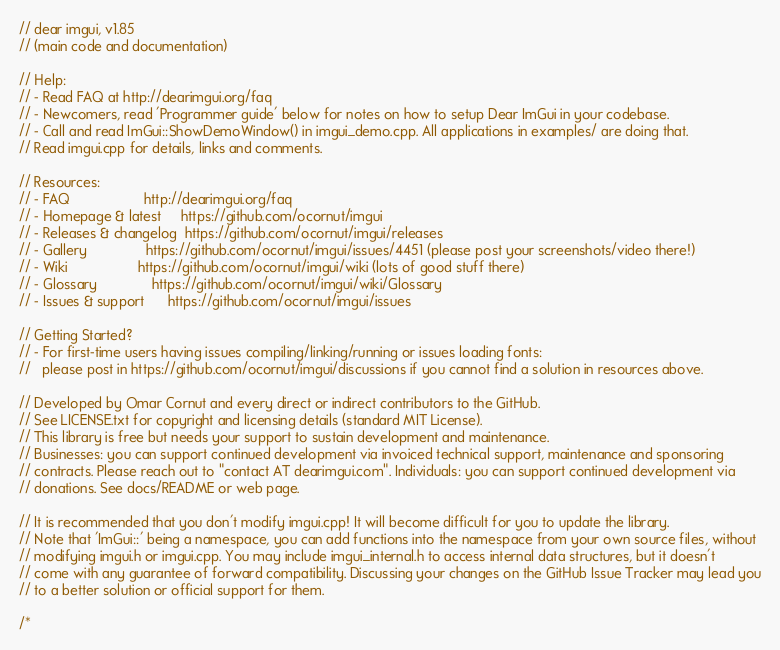<code> <loc_0><loc_0><loc_500><loc_500><_C++_>// dear imgui, v1.85
// (main code and documentation)

// Help:
// - Read FAQ at http://dearimgui.org/faq
// - Newcomers, read 'Programmer guide' below for notes on how to setup Dear ImGui in your codebase.
// - Call and read ImGui::ShowDemoWindow() in imgui_demo.cpp. All applications in examples/ are doing that.
// Read imgui.cpp for details, links and comments.

// Resources:
// - FAQ                   http://dearimgui.org/faq
// - Homepage & latest     https://github.com/ocornut/imgui
// - Releases & changelog  https://github.com/ocornut/imgui/releases
// - Gallery               https://github.com/ocornut/imgui/issues/4451 (please post your screenshots/video there!)
// - Wiki                  https://github.com/ocornut/imgui/wiki (lots of good stuff there)
// - Glossary              https://github.com/ocornut/imgui/wiki/Glossary
// - Issues & support      https://github.com/ocornut/imgui/issues

// Getting Started?
// - For first-time users having issues compiling/linking/running or issues loading fonts:
//   please post in https://github.com/ocornut/imgui/discussions if you cannot find a solution in resources above.

// Developed by Omar Cornut and every direct or indirect contributors to the GitHub.
// See LICENSE.txt for copyright and licensing details (standard MIT License).
// This library is free but needs your support to sustain development and maintenance.
// Businesses: you can support continued development via invoiced technical support, maintenance and sponsoring
// contracts. Please reach out to "contact AT dearimgui.com". Individuals: you can support continued development via
// donations. See docs/README or web page.

// It is recommended that you don't modify imgui.cpp! It will become difficult for you to update the library.
// Note that 'ImGui::' being a namespace, you can add functions into the namespace from your own source files, without
// modifying imgui.h or imgui.cpp. You may include imgui_internal.h to access internal data structures, but it doesn't
// come with any guarantee of forward compatibility. Discussing your changes on the GitHub Issue Tracker may lead you
// to a better solution or official support for them.

/*
</code> 